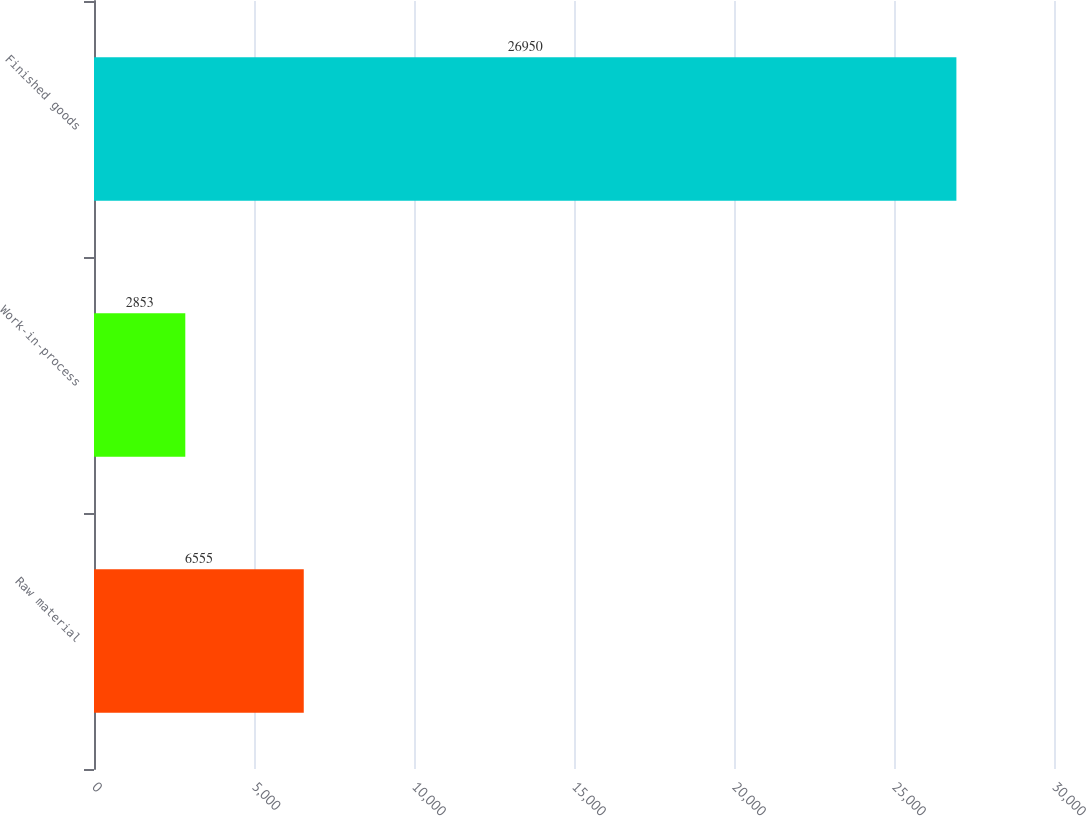Convert chart. <chart><loc_0><loc_0><loc_500><loc_500><bar_chart><fcel>Raw material<fcel>Work-in-process<fcel>Finished goods<nl><fcel>6555<fcel>2853<fcel>26950<nl></chart> 